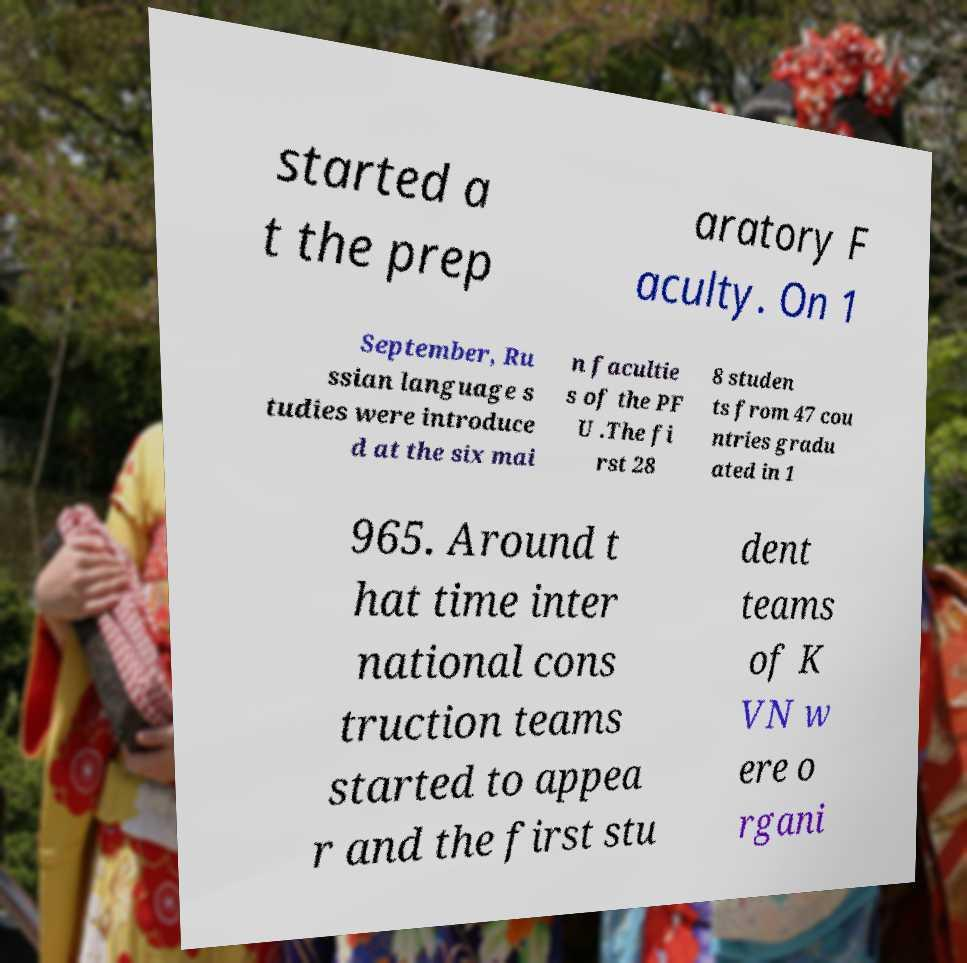Please read and relay the text visible in this image. What does it say? started a t the prep aratory F aculty. On 1 September, Ru ssian language s tudies were introduce d at the six mai n facultie s of the PF U .The fi rst 28 8 studen ts from 47 cou ntries gradu ated in 1 965. Around t hat time inter national cons truction teams started to appea r and the first stu dent teams of K VN w ere o rgani 